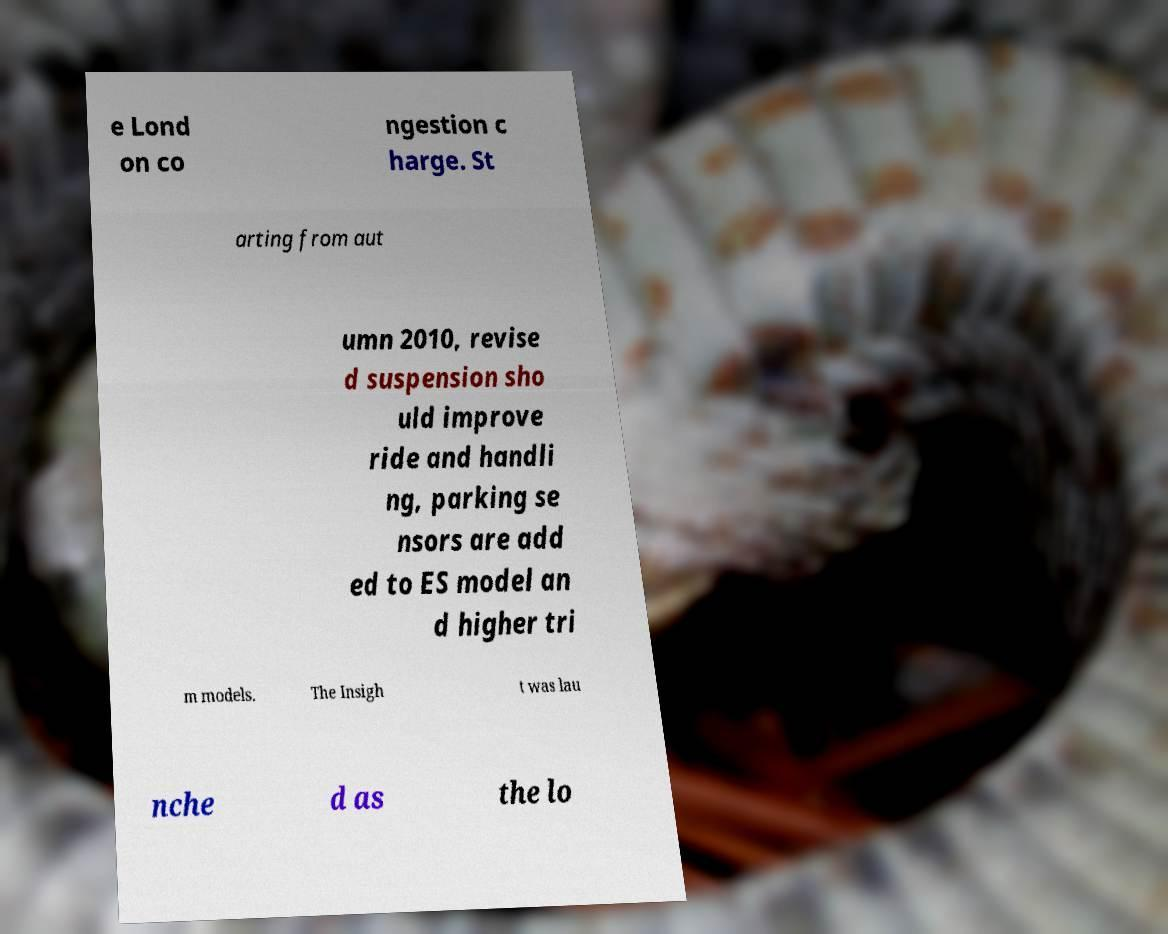For documentation purposes, I need the text within this image transcribed. Could you provide that? e Lond on co ngestion c harge. St arting from aut umn 2010, revise d suspension sho uld improve ride and handli ng, parking se nsors are add ed to ES model an d higher tri m models. The Insigh t was lau nche d as the lo 